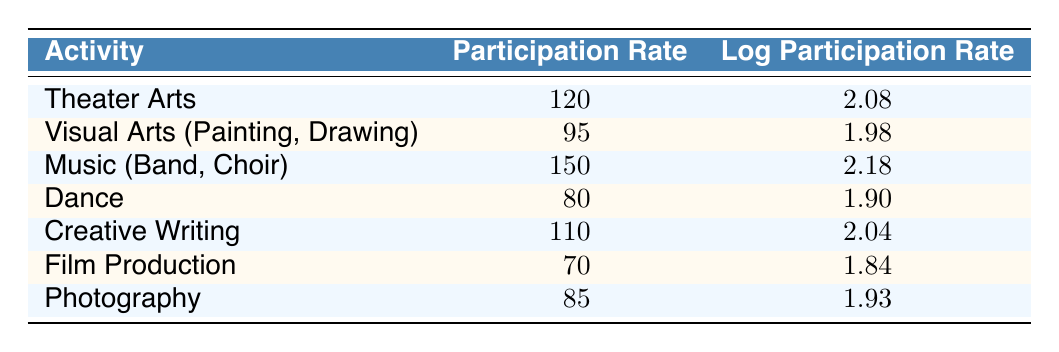What is the participation rate for Music (Band, Choir)? The participation rate for Music (Band, Choir) can be found in the table under the corresponding activity. It shows a value of 150.
Answer: 150 Which activity has the lowest participation rate? By examining the participation rates listed in the table, Dance has the lowest rate at 80.
Answer: Dance What is the average participation rate of all activities listed? First, we sum the participation rates: 120 + 95 + 150 + 80 + 110 + 70 + 85 = 910. Then, we divide by the number of activities, which is 7. Therefore, 910/7 = 130.
Answer: 130 Is the log participation rate for Creative Writing higher than that for Photography? The log participation rate for Creative Writing is 2.04, while for Photography it is 1.93. Since 2.04 is greater than 1.93, the statement is true.
Answer: Yes What is the difference in participation rates between Theater Arts and Film Production? The participation rate for Theater Arts is 120, and for Film Production, it is 70. The difference is 120 - 70 = 50.
Answer: 50 Which activities have participation rates above 100? Looking at the table, the activities with participation rates above 100 are Theater Arts (120), Music (Band, Choir) (150), and Creative Writing (110).
Answer: Theater Arts, Music (Band, Choir), Creative Writing What is the total participation rate for all creative arts activities? We sum the participation rates for all activities. The calculation is 120 + 95 + 150 + 80 + 110 + 70 + 85 = 910.
Answer: 910 How many activities have a log participation rate greater than 2.0? The table shows that the activities Theater Arts (2.08), Music (Band, Choir) (2.18), and Creative Writing (2.04) have log participation rates greater than 2.0. Thus, there are three such activities.
Answer: 3 Is there any activity with a participation rate between 80 and 90? Reviewing the participation rates, Dance (80) is at the lower bound of this range, and Photography (85) falls within it. This confirms that there are activities meeting the criteria.
Answer: Yes 